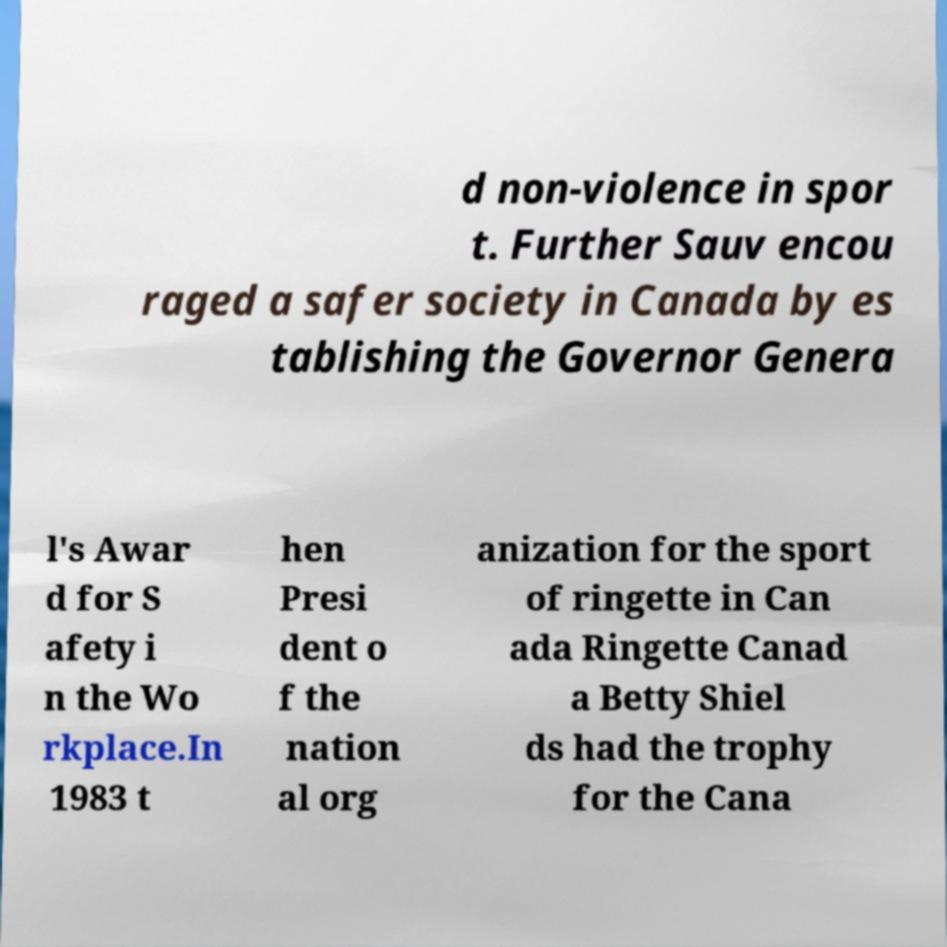Please read and relay the text visible in this image. What does it say? d non-violence in spor t. Further Sauv encou raged a safer society in Canada by es tablishing the Governor Genera l's Awar d for S afety i n the Wo rkplace.In 1983 t hen Presi dent o f the nation al org anization for the sport of ringette in Can ada Ringette Canad a Betty Shiel ds had the trophy for the Cana 